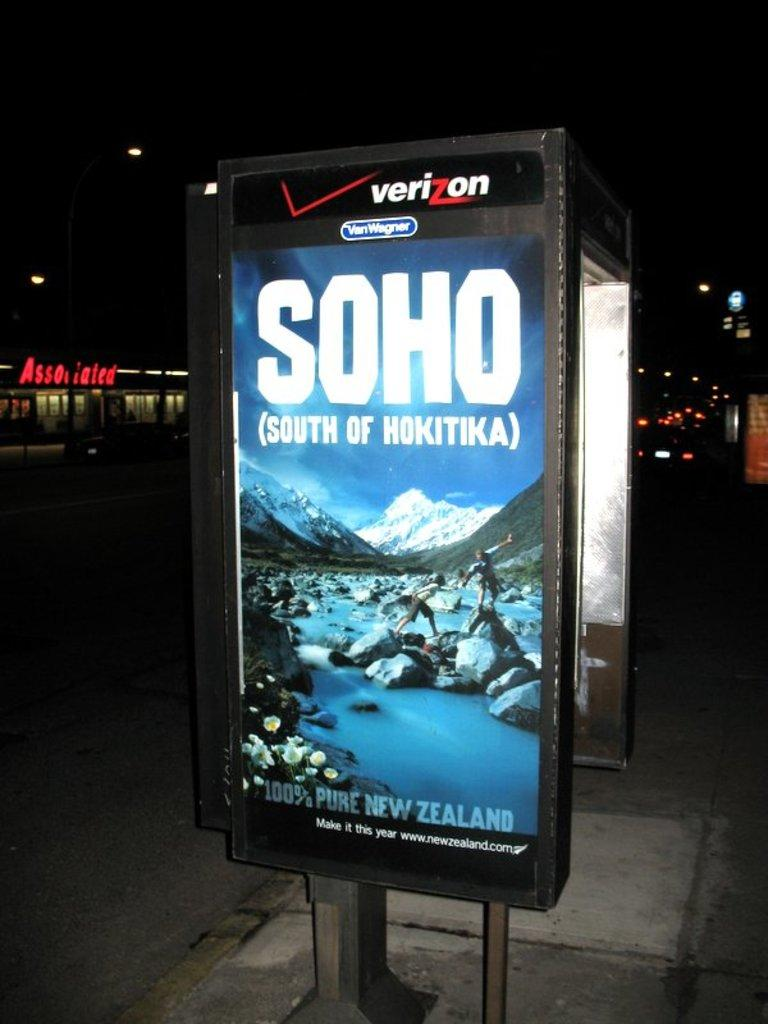<image>
Present a compact description of the photo's key features. a sign outside that says 'verizon' at the top of it 